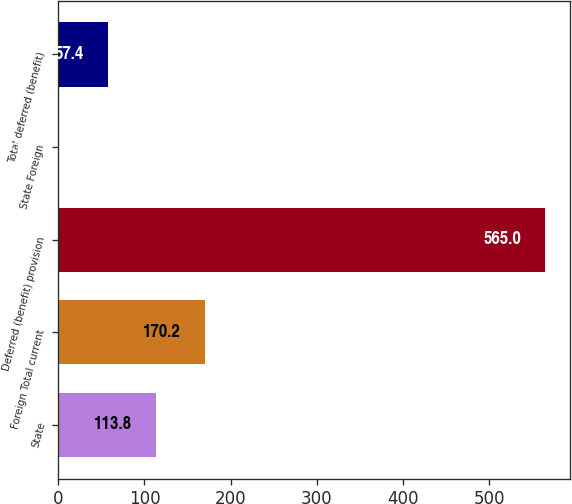Convert chart. <chart><loc_0><loc_0><loc_500><loc_500><bar_chart><fcel>State<fcel>Foreign Total current<fcel>Deferred (benefit) provision<fcel>State Foreign<fcel>Total deferred (benefit)<nl><fcel>113.8<fcel>170.2<fcel>565<fcel>1<fcel>57.4<nl></chart> 